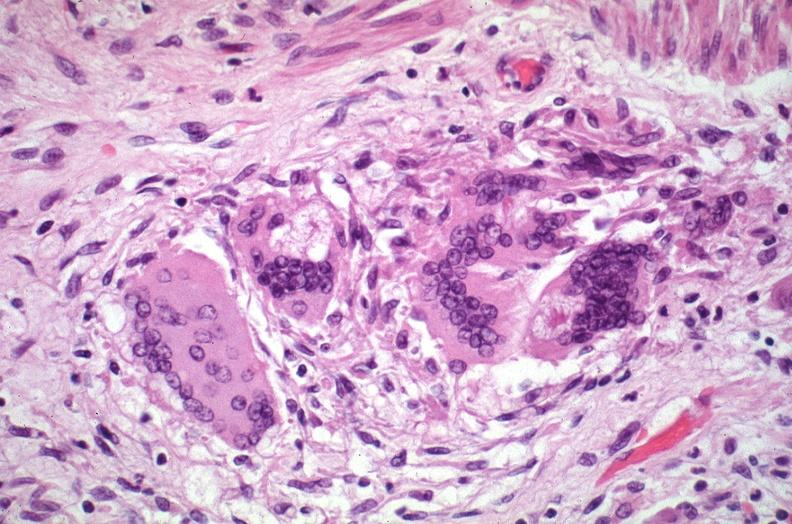does this image show lung, sarcoidosis, multinucleated giant cells with asteroid bodies?
Answer the question using a single word or phrase. Yes 